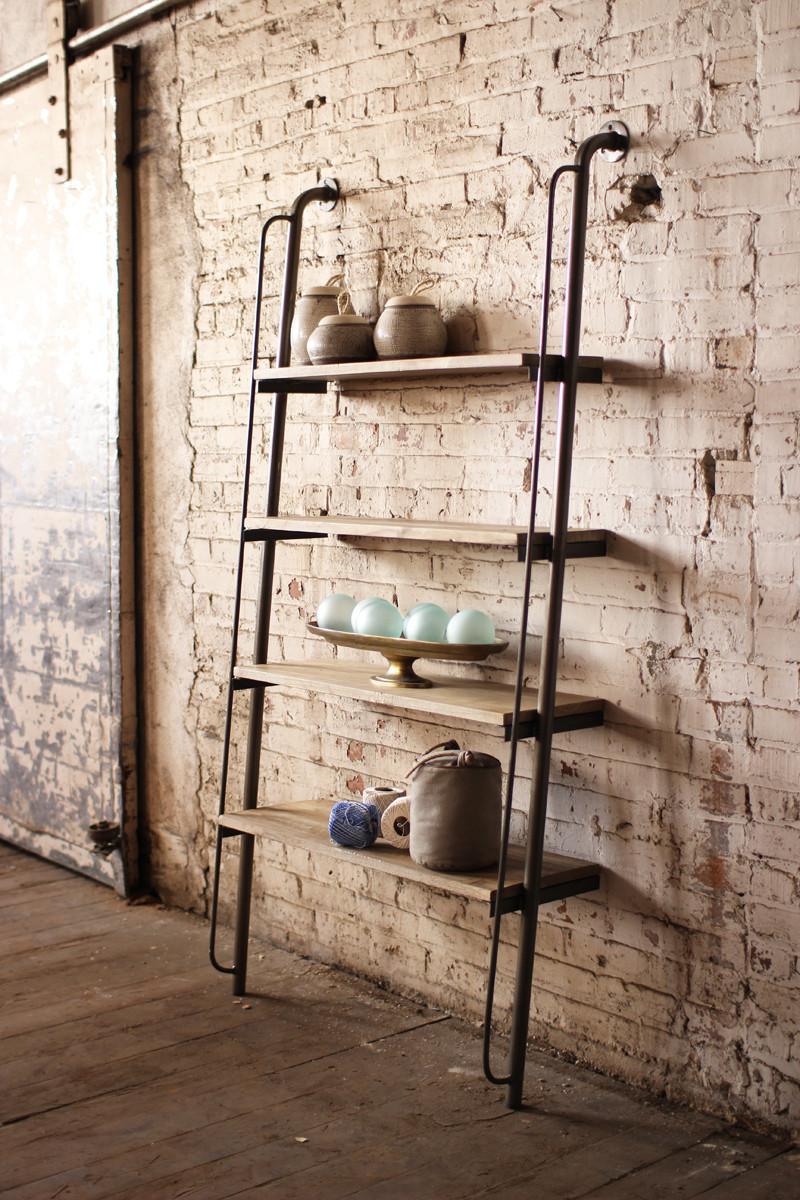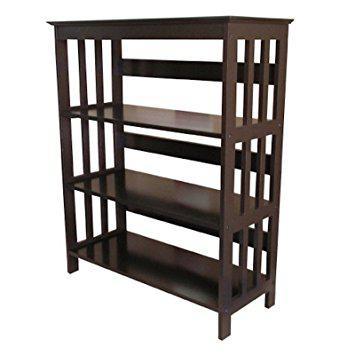The first image is the image on the left, the second image is the image on the right. Evaluate the accuracy of this statement regarding the images: "at least one bookshelf is empty". Is it true? Answer yes or no. Yes. The first image is the image on the left, the second image is the image on the right. Given the left and right images, does the statement "One of the shelving units is up against a wall." hold true? Answer yes or no. Yes. 